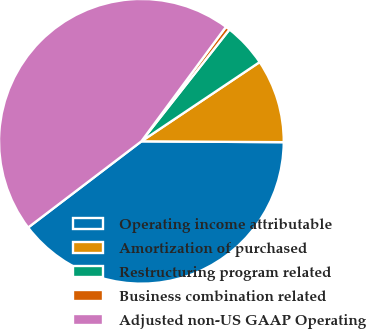Convert chart to OTSL. <chart><loc_0><loc_0><loc_500><loc_500><pie_chart><fcel>Operating income attributable<fcel>Amortization of purchased<fcel>Restructuring program related<fcel>Business combination related<fcel>Adjusted non-US GAAP Operating<nl><fcel>39.55%<fcel>9.49%<fcel>4.99%<fcel>0.49%<fcel>45.48%<nl></chart> 